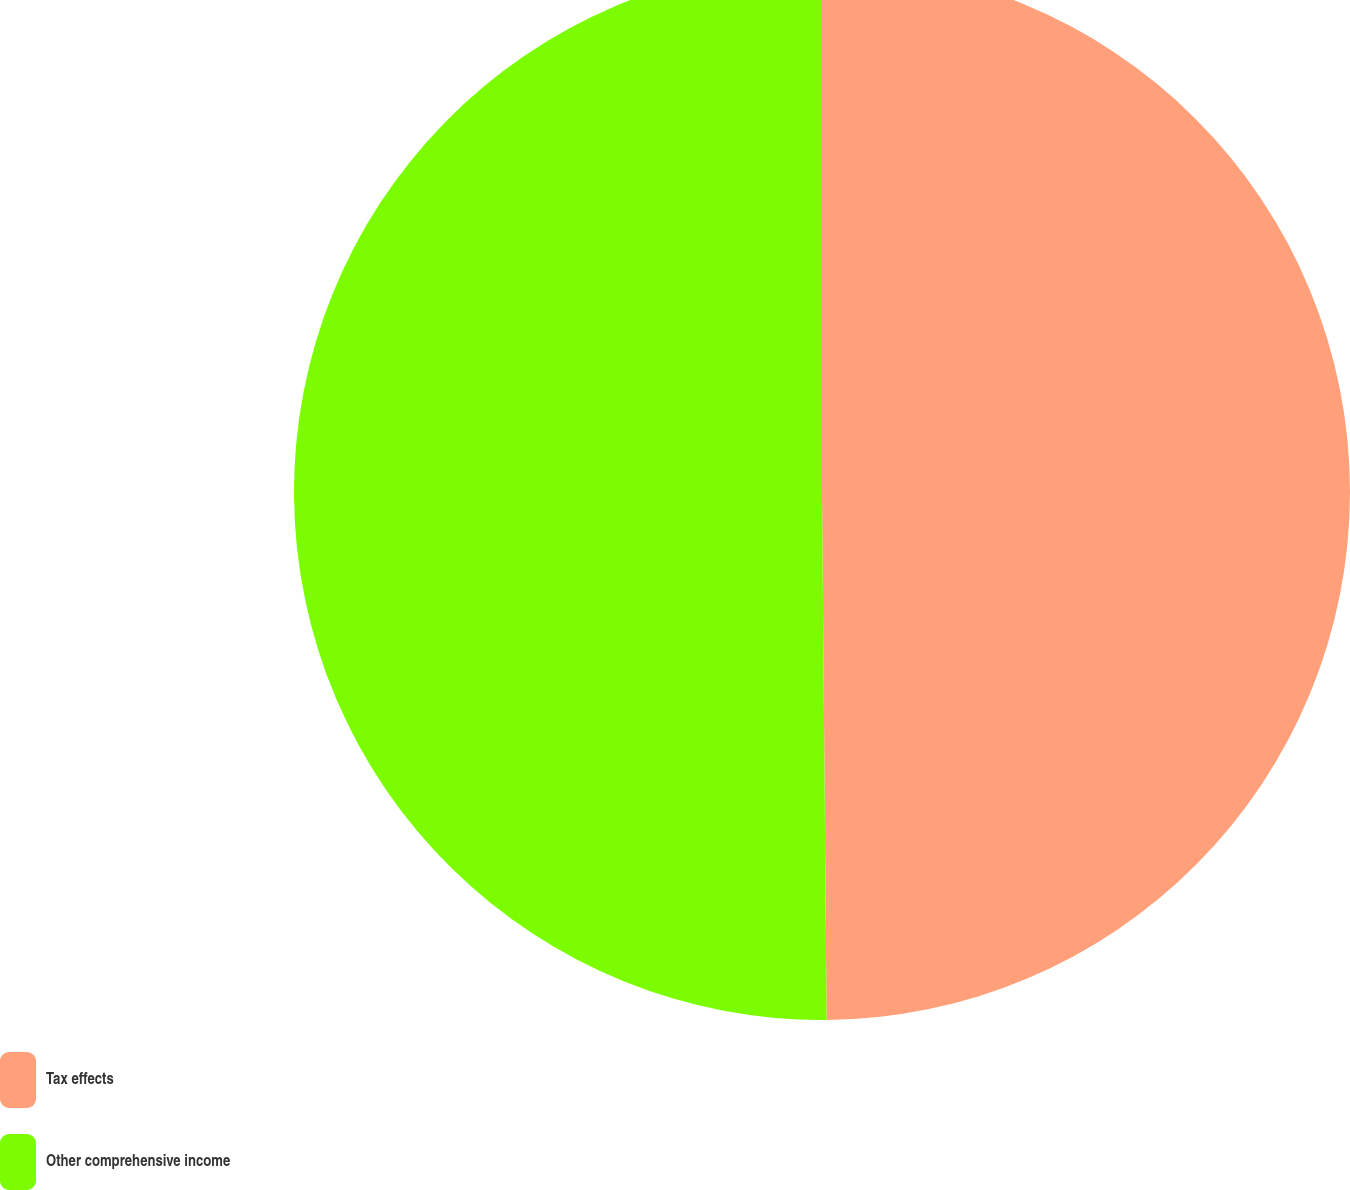Convert chart. <chart><loc_0><loc_0><loc_500><loc_500><pie_chart><fcel>Tax effects<fcel>Other comprehensive income<nl><fcel>49.86%<fcel>50.14%<nl></chart> 